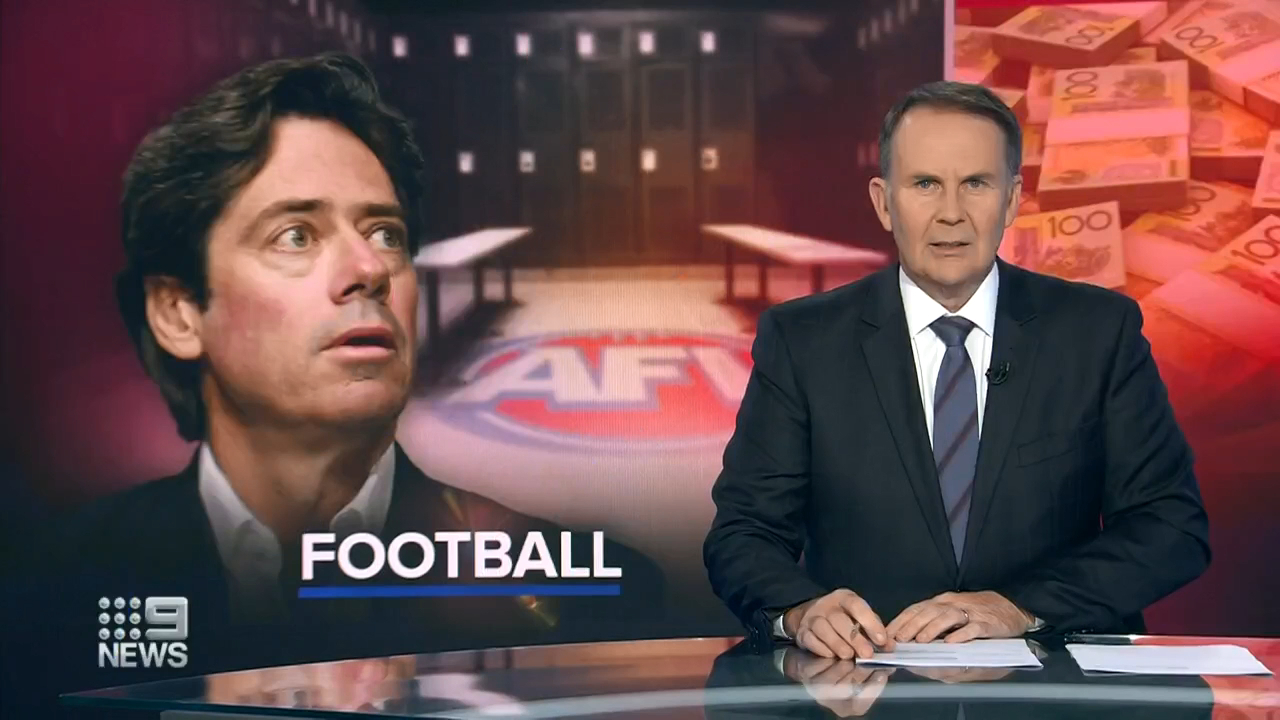Can you imagine a futuristic scenario where financial issues are completely resolved in sports? What would that look like? Imagine a futuristic world where advanced AI and blockchain technologies have revolutionized the financial landscape in sports. In this scenario, universal transparency rules out corruption, as every financial transaction is recorded on an immutable ledger accessible to all stakeholders. AI-driven financial strategies ensure optimal budget utilization, reducing waste and maximizing resource distribution. Sponsorships and advertisement revenues are managed through smart contracts that automatically allocate funds when performance metrics are met. Fans have a say in financial decisions through decentralized voting systems, fostering a transparent and inclusive community. This equilibrium promotes fair play, nurtures talent development, and ensures the longevity and prosperity of sports organizations. 